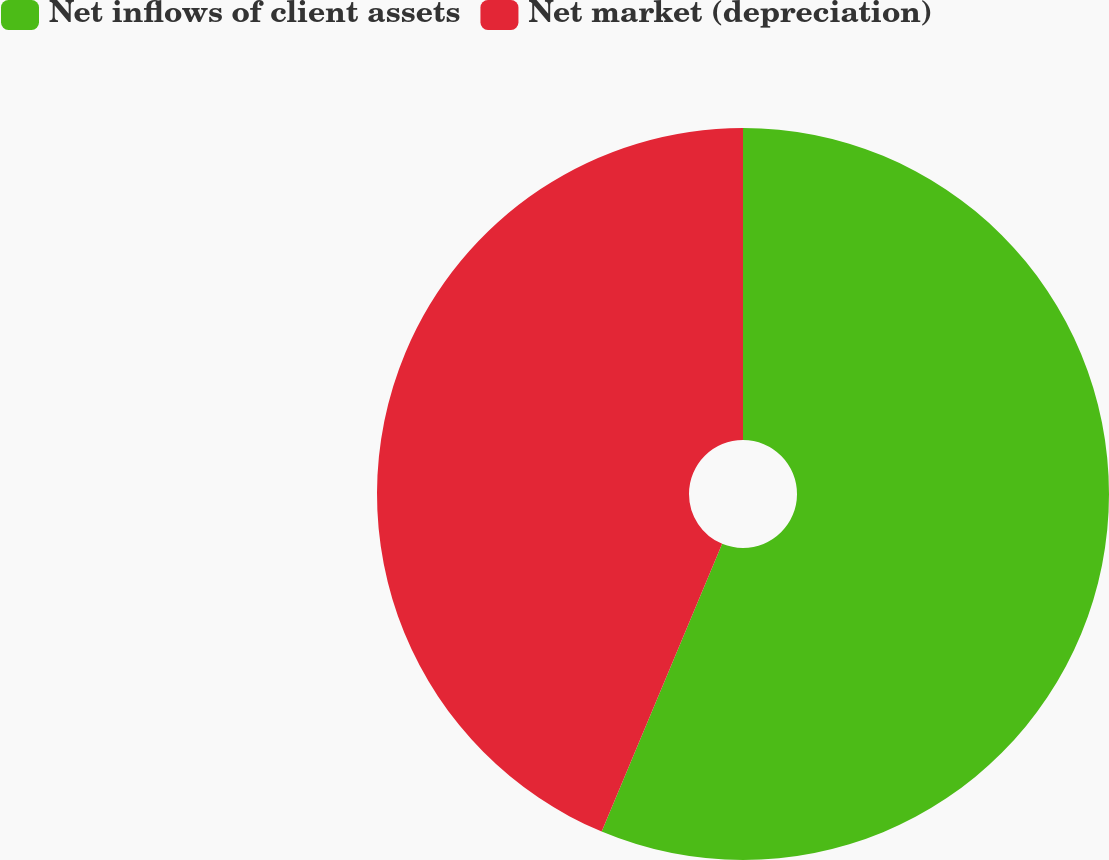<chart> <loc_0><loc_0><loc_500><loc_500><pie_chart><fcel>Net inflows of client assets<fcel>Net market (depreciation)<nl><fcel>56.31%<fcel>43.69%<nl></chart> 